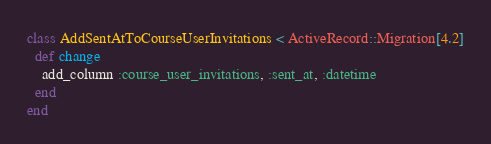Convert code to text. <code><loc_0><loc_0><loc_500><loc_500><_Ruby_>class AddSentAtToCourseUserInvitations < ActiveRecord::Migration[4.2]
  def change
    add_column :course_user_invitations, :sent_at, :datetime
  end
end
</code> 